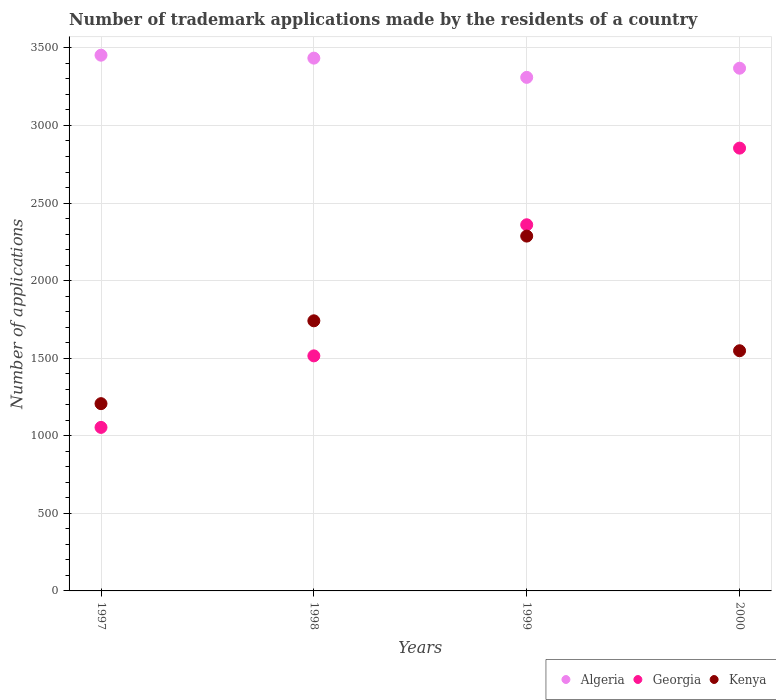Is the number of dotlines equal to the number of legend labels?
Ensure brevity in your answer.  Yes. What is the number of trademark applications made by the residents in Georgia in 2000?
Offer a very short reply. 2854. Across all years, what is the maximum number of trademark applications made by the residents in Georgia?
Provide a short and direct response. 2854. Across all years, what is the minimum number of trademark applications made by the residents in Algeria?
Your response must be concise. 3310. In which year was the number of trademark applications made by the residents in Kenya maximum?
Provide a short and direct response. 1999. What is the total number of trademark applications made by the residents in Algeria in the graph?
Ensure brevity in your answer.  1.36e+04. What is the difference between the number of trademark applications made by the residents in Kenya in 1997 and that in 1999?
Offer a terse response. -1080. What is the difference between the number of trademark applications made by the residents in Kenya in 1998 and the number of trademark applications made by the residents in Georgia in 1999?
Offer a very short reply. -619. What is the average number of trademark applications made by the residents in Georgia per year?
Give a very brief answer. 1945.75. In the year 1998, what is the difference between the number of trademark applications made by the residents in Georgia and number of trademark applications made by the residents in Kenya?
Make the answer very short. -226. In how many years, is the number of trademark applications made by the residents in Georgia greater than 3300?
Offer a terse response. 0. What is the ratio of the number of trademark applications made by the residents in Algeria in 1998 to that in 1999?
Provide a succinct answer. 1.04. What is the difference between the highest and the second highest number of trademark applications made by the residents in Kenya?
Offer a very short reply. 546. What is the difference between the highest and the lowest number of trademark applications made by the residents in Kenya?
Keep it short and to the point. 1080. Does the number of trademark applications made by the residents in Kenya monotonically increase over the years?
Your response must be concise. No. How many years are there in the graph?
Give a very brief answer. 4. What is the difference between two consecutive major ticks on the Y-axis?
Your answer should be compact. 500. Are the values on the major ticks of Y-axis written in scientific E-notation?
Ensure brevity in your answer.  No. Does the graph contain any zero values?
Ensure brevity in your answer.  No. Does the graph contain grids?
Provide a succinct answer. Yes. How are the legend labels stacked?
Provide a short and direct response. Horizontal. What is the title of the graph?
Offer a very short reply. Number of trademark applications made by the residents of a country. What is the label or title of the Y-axis?
Your response must be concise. Number of applications. What is the Number of applications in Algeria in 1997?
Offer a very short reply. 3453. What is the Number of applications of Georgia in 1997?
Your answer should be compact. 1054. What is the Number of applications in Kenya in 1997?
Make the answer very short. 1207. What is the Number of applications in Algeria in 1998?
Provide a short and direct response. 3434. What is the Number of applications of Georgia in 1998?
Keep it short and to the point. 1515. What is the Number of applications in Kenya in 1998?
Your answer should be very brief. 1741. What is the Number of applications of Algeria in 1999?
Your answer should be very brief. 3310. What is the Number of applications in Georgia in 1999?
Your response must be concise. 2360. What is the Number of applications in Kenya in 1999?
Offer a very short reply. 2287. What is the Number of applications in Algeria in 2000?
Offer a terse response. 3369. What is the Number of applications in Georgia in 2000?
Keep it short and to the point. 2854. What is the Number of applications of Kenya in 2000?
Offer a very short reply. 1548. Across all years, what is the maximum Number of applications in Algeria?
Your response must be concise. 3453. Across all years, what is the maximum Number of applications of Georgia?
Make the answer very short. 2854. Across all years, what is the maximum Number of applications of Kenya?
Keep it short and to the point. 2287. Across all years, what is the minimum Number of applications in Algeria?
Your response must be concise. 3310. Across all years, what is the minimum Number of applications of Georgia?
Keep it short and to the point. 1054. Across all years, what is the minimum Number of applications in Kenya?
Provide a short and direct response. 1207. What is the total Number of applications of Algeria in the graph?
Your response must be concise. 1.36e+04. What is the total Number of applications of Georgia in the graph?
Your answer should be very brief. 7783. What is the total Number of applications of Kenya in the graph?
Your answer should be compact. 6783. What is the difference between the Number of applications in Algeria in 1997 and that in 1998?
Give a very brief answer. 19. What is the difference between the Number of applications of Georgia in 1997 and that in 1998?
Provide a succinct answer. -461. What is the difference between the Number of applications in Kenya in 1997 and that in 1998?
Ensure brevity in your answer.  -534. What is the difference between the Number of applications of Algeria in 1997 and that in 1999?
Provide a succinct answer. 143. What is the difference between the Number of applications of Georgia in 1997 and that in 1999?
Ensure brevity in your answer.  -1306. What is the difference between the Number of applications in Kenya in 1997 and that in 1999?
Offer a terse response. -1080. What is the difference between the Number of applications in Algeria in 1997 and that in 2000?
Your answer should be very brief. 84. What is the difference between the Number of applications in Georgia in 1997 and that in 2000?
Make the answer very short. -1800. What is the difference between the Number of applications of Kenya in 1997 and that in 2000?
Ensure brevity in your answer.  -341. What is the difference between the Number of applications of Algeria in 1998 and that in 1999?
Give a very brief answer. 124. What is the difference between the Number of applications of Georgia in 1998 and that in 1999?
Provide a succinct answer. -845. What is the difference between the Number of applications of Kenya in 1998 and that in 1999?
Your answer should be very brief. -546. What is the difference between the Number of applications in Algeria in 1998 and that in 2000?
Provide a succinct answer. 65. What is the difference between the Number of applications in Georgia in 1998 and that in 2000?
Your answer should be compact. -1339. What is the difference between the Number of applications in Kenya in 1998 and that in 2000?
Keep it short and to the point. 193. What is the difference between the Number of applications of Algeria in 1999 and that in 2000?
Keep it short and to the point. -59. What is the difference between the Number of applications of Georgia in 1999 and that in 2000?
Provide a succinct answer. -494. What is the difference between the Number of applications in Kenya in 1999 and that in 2000?
Provide a succinct answer. 739. What is the difference between the Number of applications of Algeria in 1997 and the Number of applications of Georgia in 1998?
Your response must be concise. 1938. What is the difference between the Number of applications of Algeria in 1997 and the Number of applications of Kenya in 1998?
Give a very brief answer. 1712. What is the difference between the Number of applications in Georgia in 1997 and the Number of applications in Kenya in 1998?
Provide a short and direct response. -687. What is the difference between the Number of applications of Algeria in 1997 and the Number of applications of Georgia in 1999?
Offer a very short reply. 1093. What is the difference between the Number of applications of Algeria in 1997 and the Number of applications of Kenya in 1999?
Ensure brevity in your answer.  1166. What is the difference between the Number of applications of Georgia in 1997 and the Number of applications of Kenya in 1999?
Your answer should be compact. -1233. What is the difference between the Number of applications of Algeria in 1997 and the Number of applications of Georgia in 2000?
Give a very brief answer. 599. What is the difference between the Number of applications of Algeria in 1997 and the Number of applications of Kenya in 2000?
Offer a very short reply. 1905. What is the difference between the Number of applications of Georgia in 1997 and the Number of applications of Kenya in 2000?
Keep it short and to the point. -494. What is the difference between the Number of applications of Algeria in 1998 and the Number of applications of Georgia in 1999?
Offer a very short reply. 1074. What is the difference between the Number of applications in Algeria in 1998 and the Number of applications in Kenya in 1999?
Your response must be concise. 1147. What is the difference between the Number of applications of Georgia in 1998 and the Number of applications of Kenya in 1999?
Your answer should be very brief. -772. What is the difference between the Number of applications in Algeria in 1998 and the Number of applications in Georgia in 2000?
Your answer should be compact. 580. What is the difference between the Number of applications in Algeria in 1998 and the Number of applications in Kenya in 2000?
Offer a very short reply. 1886. What is the difference between the Number of applications of Georgia in 1998 and the Number of applications of Kenya in 2000?
Offer a very short reply. -33. What is the difference between the Number of applications in Algeria in 1999 and the Number of applications in Georgia in 2000?
Offer a terse response. 456. What is the difference between the Number of applications of Algeria in 1999 and the Number of applications of Kenya in 2000?
Provide a short and direct response. 1762. What is the difference between the Number of applications of Georgia in 1999 and the Number of applications of Kenya in 2000?
Your answer should be compact. 812. What is the average Number of applications of Algeria per year?
Offer a very short reply. 3391.5. What is the average Number of applications of Georgia per year?
Your answer should be compact. 1945.75. What is the average Number of applications in Kenya per year?
Make the answer very short. 1695.75. In the year 1997, what is the difference between the Number of applications of Algeria and Number of applications of Georgia?
Offer a terse response. 2399. In the year 1997, what is the difference between the Number of applications in Algeria and Number of applications in Kenya?
Offer a terse response. 2246. In the year 1997, what is the difference between the Number of applications in Georgia and Number of applications in Kenya?
Ensure brevity in your answer.  -153. In the year 1998, what is the difference between the Number of applications in Algeria and Number of applications in Georgia?
Your response must be concise. 1919. In the year 1998, what is the difference between the Number of applications of Algeria and Number of applications of Kenya?
Provide a short and direct response. 1693. In the year 1998, what is the difference between the Number of applications of Georgia and Number of applications of Kenya?
Provide a succinct answer. -226. In the year 1999, what is the difference between the Number of applications in Algeria and Number of applications in Georgia?
Provide a succinct answer. 950. In the year 1999, what is the difference between the Number of applications in Algeria and Number of applications in Kenya?
Offer a very short reply. 1023. In the year 2000, what is the difference between the Number of applications of Algeria and Number of applications of Georgia?
Keep it short and to the point. 515. In the year 2000, what is the difference between the Number of applications of Algeria and Number of applications of Kenya?
Your answer should be very brief. 1821. In the year 2000, what is the difference between the Number of applications of Georgia and Number of applications of Kenya?
Provide a short and direct response. 1306. What is the ratio of the Number of applications of Georgia in 1997 to that in 1998?
Offer a very short reply. 0.7. What is the ratio of the Number of applications of Kenya in 1997 to that in 1998?
Make the answer very short. 0.69. What is the ratio of the Number of applications in Algeria in 1997 to that in 1999?
Provide a succinct answer. 1.04. What is the ratio of the Number of applications of Georgia in 1997 to that in 1999?
Offer a very short reply. 0.45. What is the ratio of the Number of applications in Kenya in 1997 to that in 1999?
Your answer should be compact. 0.53. What is the ratio of the Number of applications in Algeria in 1997 to that in 2000?
Your answer should be compact. 1.02. What is the ratio of the Number of applications of Georgia in 1997 to that in 2000?
Provide a short and direct response. 0.37. What is the ratio of the Number of applications of Kenya in 1997 to that in 2000?
Provide a short and direct response. 0.78. What is the ratio of the Number of applications in Algeria in 1998 to that in 1999?
Keep it short and to the point. 1.04. What is the ratio of the Number of applications of Georgia in 1998 to that in 1999?
Your answer should be very brief. 0.64. What is the ratio of the Number of applications of Kenya in 1998 to that in 1999?
Provide a succinct answer. 0.76. What is the ratio of the Number of applications in Algeria in 1998 to that in 2000?
Your answer should be compact. 1.02. What is the ratio of the Number of applications of Georgia in 1998 to that in 2000?
Keep it short and to the point. 0.53. What is the ratio of the Number of applications of Kenya in 1998 to that in 2000?
Make the answer very short. 1.12. What is the ratio of the Number of applications of Algeria in 1999 to that in 2000?
Keep it short and to the point. 0.98. What is the ratio of the Number of applications of Georgia in 1999 to that in 2000?
Provide a short and direct response. 0.83. What is the ratio of the Number of applications in Kenya in 1999 to that in 2000?
Offer a very short reply. 1.48. What is the difference between the highest and the second highest Number of applications of Algeria?
Provide a short and direct response. 19. What is the difference between the highest and the second highest Number of applications in Georgia?
Your response must be concise. 494. What is the difference between the highest and the second highest Number of applications of Kenya?
Provide a short and direct response. 546. What is the difference between the highest and the lowest Number of applications in Algeria?
Your answer should be very brief. 143. What is the difference between the highest and the lowest Number of applications of Georgia?
Offer a terse response. 1800. What is the difference between the highest and the lowest Number of applications of Kenya?
Offer a very short reply. 1080. 